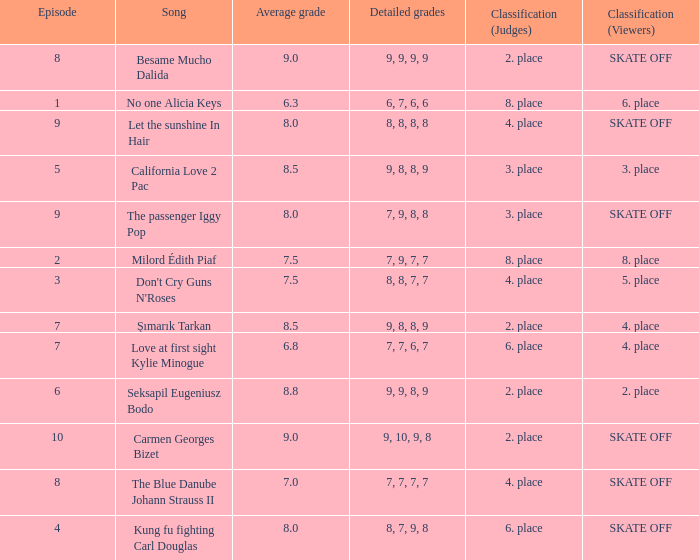Name the classification for 9, 9, 8, 9 2. place. 